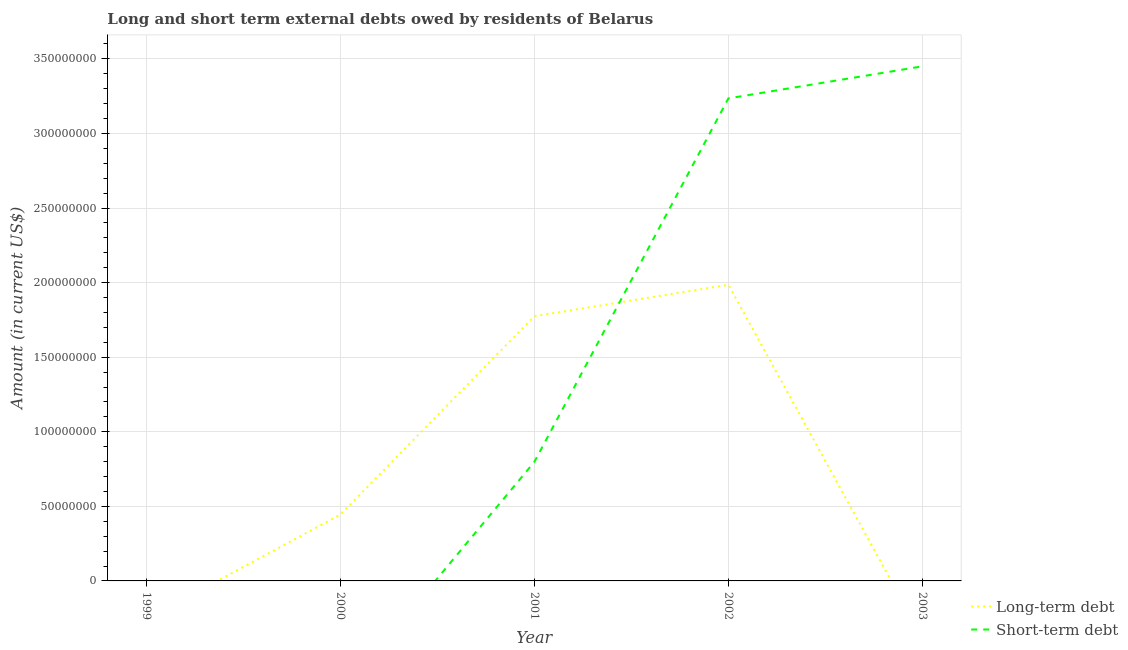Does the line corresponding to long-term debts owed by residents intersect with the line corresponding to short-term debts owed by residents?
Offer a terse response. Yes. Is the number of lines equal to the number of legend labels?
Keep it short and to the point. No. What is the short-term debts owed by residents in 2003?
Your response must be concise. 3.45e+08. Across all years, what is the maximum long-term debts owed by residents?
Keep it short and to the point. 1.99e+08. What is the total long-term debts owed by residents in the graph?
Ensure brevity in your answer.  4.20e+08. What is the difference between the long-term debts owed by residents in 2000 and that in 2001?
Give a very brief answer. -1.33e+08. What is the difference between the short-term debts owed by residents in 1999 and the long-term debts owed by residents in 2000?
Provide a short and direct response. -4.45e+07. What is the average long-term debts owed by residents per year?
Provide a succinct answer. 8.41e+07. In the year 2002, what is the difference between the short-term debts owed by residents and long-term debts owed by residents?
Make the answer very short. 1.25e+08. What is the difference between the highest and the second highest short-term debts owed by residents?
Make the answer very short. 2.15e+07. What is the difference between the highest and the lowest short-term debts owed by residents?
Your answer should be very brief. 3.45e+08. Is the long-term debts owed by residents strictly greater than the short-term debts owed by residents over the years?
Your response must be concise. No. Is the long-term debts owed by residents strictly less than the short-term debts owed by residents over the years?
Ensure brevity in your answer.  No. How many lines are there?
Provide a short and direct response. 2. Are the values on the major ticks of Y-axis written in scientific E-notation?
Keep it short and to the point. No. Does the graph contain any zero values?
Your answer should be very brief. Yes. How many legend labels are there?
Ensure brevity in your answer.  2. How are the legend labels stacked?
Offer a terse response. Vertical. What is the title of the graph?
Provide a short and direct response. Long and short term external debts owed by residents of Belarus. What is the label or title of the X-axis?
Offer a very short reply. Year. What is the Amount (in current US$) in Long-term debt in 1999?
Give a very brief answer. 0. What is the Amount (in current US$) of Long-term debt in 2000?
Give a very brief answer. 4.45e+07. What is the Amount (in current US$) in Short-term debt in 2000?
Your answer should be very brief. 0. What is the Amount (in current US$) in Long-term debt in 2001?
Ensure brevity in your answer.  1.77e+08. What is the Amount (in current US$) in Short-term debt in 2001?
Provide a succinct answer. 7.98e+07. What is the Amount (in current US$) of Long-term debt in 2002?
Make the answer very short. 1.99e+08. What is the Amount (in current US$) of Short-term debt in 2002?
Provide a short and direct response. 3.24e+08. What is the Amount (in current US$) in Long-term debt in 2003?
Provide a succinct answer. 0. What is the Amount (in current US$) in Short-term debt in 2003?
Ensure brevity in your answer.  3.45e+08. Across all years, what is the maximum Amount (in current US$) in Long-term debt?
Your response must be concise. 1.99e+08. Across all years, what is the maximum Amount (in current US$) in Short-term debt?
Your response must be concise. 3.45e+08. Across all years, what is the minimum Amount (in current US$) of Long-term debt?
Give a very brief answer. 0. What is the total Amount (in current US$) of Long-term debt in the graph?
Give a very brief answer. 4.20e+08. What is the total Amount (in current US$) of Short-term debt in the graph?
Offer a very short reply. 7.48e+08. What is the difference between the Amount (in current US$) in Long-term debt in 2000 and that in 2001?
Give a very brief answer. -1.33e+08. What is the difference between the Amount (in current US$) of Long-term debt in 2000 and that in 2002?
Your response must be concise. -1.54e+08. What is the difference between the Amount (in current US$) of Long-term debt in 2001 and that in 2002?
Offer a very short reply. -2.11e+07. What is the difference between the Amount (in current US$) in Short-term debt in 2001 and that in 2002?
Ensure brevity in your answer.  -2.44e+08. What is the difference between the Amount (in current US$) of Short-term debt in 2001 and that in 2003?
Give a very brief answer. -2.65e+08. What is the difference between the Amount (in current US$) in Short-term debt in 2002 and that in 2003?
Give a very brief answer. -2.15e+07. What is the difference between the Amount (in current US$) in Long-term debt in 2000 and the Amount (in current US$) in Short-term debt in 2001?
Your answer should be very brief. -3.53e+07. What is the difference between the Amount (in current US$) of Long-term debt in 2000 and the Amount (in current US$) of Short-term debt in 2002?
Ensure brevity in your answer.  -2.79e+08. What is the difference between the Amount (in current US$) of Long-term debt in 2000 and the Amount (in current US$) of Short-term debt in 2003?
Give a very brief answer. -3.01e+08. What is the difference between the Amount (in current US$) of Long-term debt in 2001 and the Amount (in current US$) of Short-term debt in 2002?
Provide a succinct answer. -1.46e+08. What is the difference between the Amount (in current US$) of Long-term debt in 2001 and the Amount (in current US$) of Short-term debt in 2003?
Your response must be concise. -1.68e+08. What is the difference between the Amount (in current US$) of Long-term debt in 2002 and the Amount (in current US$) of Short-term debt in 2003?
Offer a terse response. -1.46e+08. What is the average Amount (in current US$) in Long-term debt per year?
Keep it short and to the point. 8.41e+07. What is the average Amount (in current US$) in Short-term debt per year?
Provide a succinct answer. 1.50e+08. In the year 2001, what is the difference between the Amount (in current US$) of Long-term debt and Amount (in current US$) of Short-term debt?
Provide a short and direct response. 9.77e+07. In the year 2002, what is the difference between the Amount (in current US$) in Long-term debt and Amount (in current US$) in Short-term debt?
Offer a terse response. -1.25e+08. What is the ratio of the Amount (in current US$) in Long-term debt in 2000 to that in 2001?
Offer a terse response. 0.25. What is the ratio of the Amount (in current US$) of Long-term debt in 2000 to that in 2002?
Offer a terse response. 0.22. What is the ratio of the Amount (in current US$) in Long-term debt in 2001 to that in 2002?
Keep it short and to the point. 0.89. What is the ratio of the Amount (in current US$) of Short-term debt in 2001 to that in 2002?
Your response must be concise. 0.25. What is the ratio of the Amount (in current US$) of Short-term debt in 2001 to that in 2003?
Provide a short and direct response. 0.23. What is the ratio of the Amount (in current US$) in Short-term debt in 2002 to that in 2003?
Ensure brevity in your answer.  0.94. What is the difference between the highest and the second highest Amount (in current US$) in Long-term debt?
Provide a succinct answer. 2.11e+07. What is the difference between the highest and the second highest Amount (in current US$) in Short-term debt?
Your response must be concise. 2.15e+07. What is the difference between the highest and the lowest Amount (in current US$) in Long-term debt?
Offer a terse response. 1.99e+08. What is the difference between the highest and the lowest Amount (in current US$) of Short-term debt?
Your answer should be compact. 3.45e+08. 